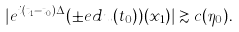<formula> <loc_0><loc_0><loc_500><loc_500>| e ^ { i ( t _ { 1 } - t _ { 0 } ) \Delta } ( \pm e d u ( t _ { 0 } ) ) ( x _ { 1 } ) | \gtrsim c ( \eta _ { 0 } ) .</formula> 